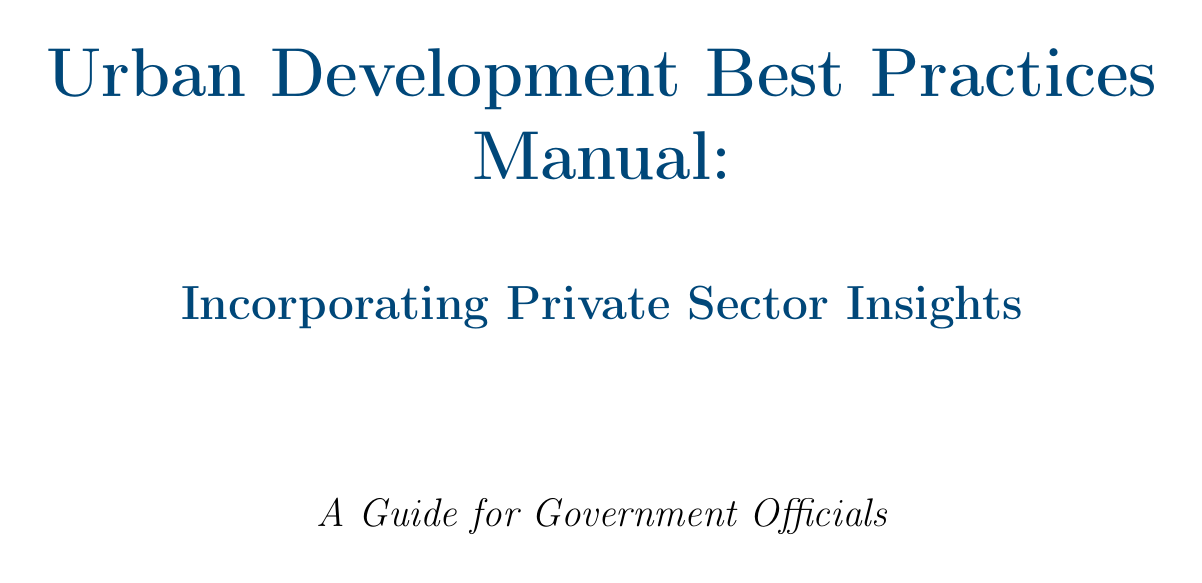What is the title of the manual? The title of the manual is explicitly stated at the beginning as "Urban Development Best Practices Manual: Incorporating Private Sector Insights".
Answer: Urban Development Best Practices Manual: Incorporating Private Sector Insights What successful development is mentioned in relation to PPPs? The document provides an example of successful PPP collaboration with the Hudson Yards development in New York City.
Answer: Hudson Yards Which companies partnered with Singapore for IoT solutions? The manual states that Singapore partnered with tech giants like IBM and Microsoft for smart city technologies.
Answer: IBM and Microsoft What does LEED stand for? The document refers to "LEED certification standards", indicating it is a recognized standard in sustainable building practices, though it does not explicitly define the acronym in the text.
Answer: LEED Which project is cited as a model for Transit-Oriented Development? The manual mentions Hong Kong's MTR Corporation as a successful model for integrating real estate development with public transportation.
Answer: Hong Kong's MTR Corporation What is one example of a non-profit developer mentioned for affordable housing? The text notes Bridge Housing as a partner for creating affordable housing on public land.
Answer: Bridge Housing What type of space does the High Line project focus on? The document specifies that the High Line project in New York is focused on creating engaging public spaces.
Answer: Engaging public spaces What innovative technology does the manual suggest working with Siemens for? The text emphasizes partnering with Siemens to explore digital twin cities for better urban planning.
Answer: Digital twin cities What does the conclusion emphasize for government officials? The conclusion reiterates the importance of incorporating private sector insights and expertise in urban development efforts.
Answer: Incorporating private sector insights and expertise 